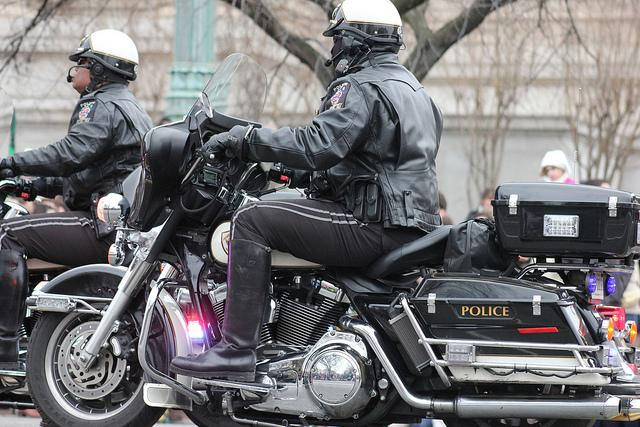What would be one main reason a police would be riding this type of motorcycle?

Choices:
A) functionality
B) easy access
C) looks
D) speed looks 